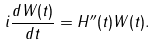<formula> <loc_0><loc_0><loc_500><loc_500>i \frac { d W ( t ) } { d t } = H ^ { \prime \prime } ( t ) W ( t ) .</formula> 